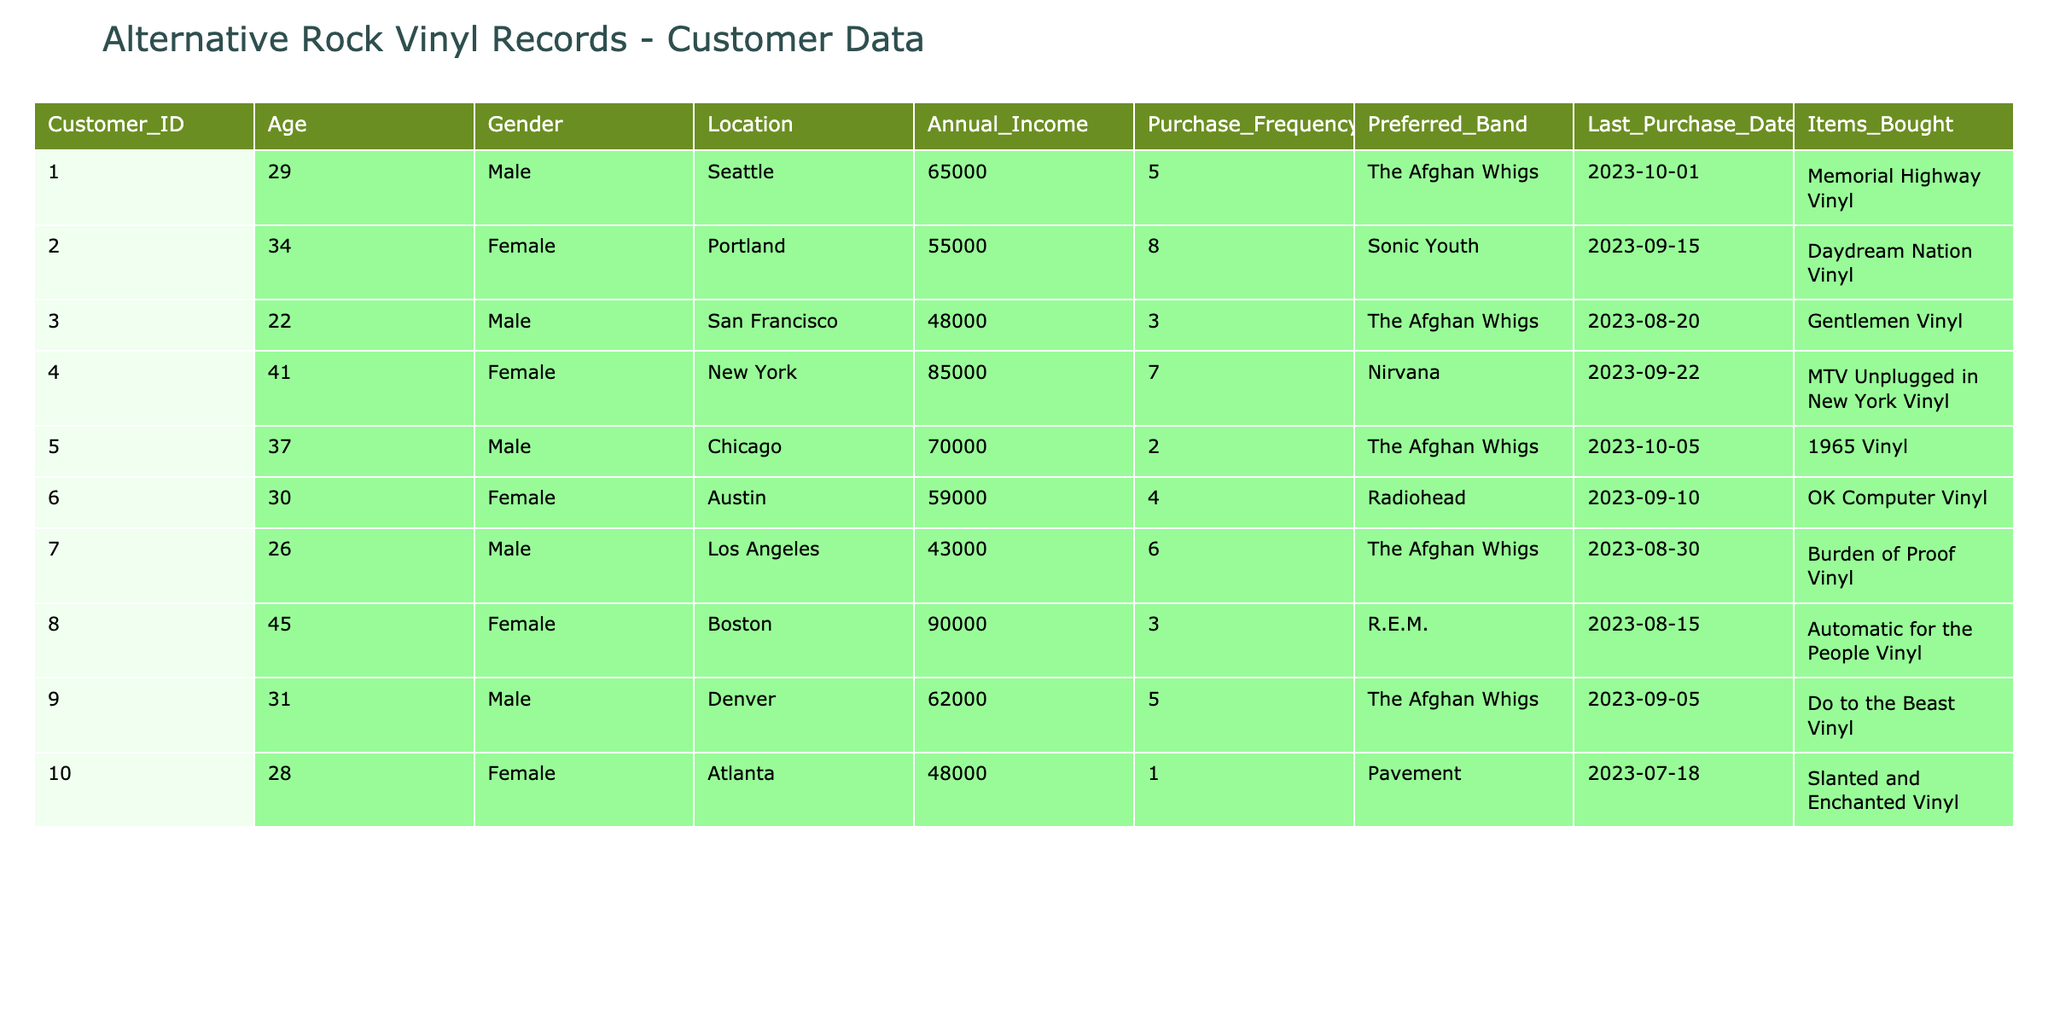What is the annual income of the customer who last purchased "Memorial Highway Vinyl"? The customer who last purchased "Memorial Highway Vinyl" is identified as Customer ID 1. Referring to the table, their annual income is listed as 65000.
Answer: 65000 What is the preferred band of the customer from Boston? The customer from Boston is identified as Customer ID 8. According to the table, their preferred band is R.E.M.
Answer: R.E.M How many customers have "The Afghan Whigs" as their preferred band? To answer this, I need to count the rows where the preferred band is "The Afghan Whigs." There are 4 customers with this preference (Customer IDs 1, 3, 5, and 7).
Answer: 4 What is the average age of the customers whose last purchase was in September 2023? First, I need to identify the customers who last purchased in September 2023, which includes Customer IDs 2, 4, 9, and 10. Their ages are 34, 41, 31, and 28 respectively. Adding these together gives a sum of 34 + 41 + 31 + 28 = 134. Since there are 4 customers, the average age is 134/4 = 33.5.
Answer: 33.5 Did any customer from Seattle have a purchase frequency of 5 or more? Looking at the information for Seattle, Customer ID 1 has a purchase frequency of 5. Therefore, the answer is Yes.
Answer: Yes Which band had the highest preferred count among the listed customers? By reviewing the preferences in the table, "The Afghan Whigs" is preferred by 4 customers. The counts for the other bands are as follows: Sonic Youth (1), Nirvana (1), Radiohead (1), R.E.M. (1), and Pavement (1). Since 4 is the highest count, "The Afghan Whigs" hold the title for the highest preferred count.
Answer: The Afghan Whigs What is the total purchase frequency of female customers? To determine this, look for female customers in the table: Customer IDs 2, 4, 6, and 8 have purchase frequencies of 8, 7, 4, and 3 respectively. The total frequency is 8 + 7 + 4 + 3 = 22.
Answer: 22 How many customers from Chicago last purchased a vinyl record in October 2023? In check for Chicago, Customer ID 5 is noted with a last purchase date of October 5, 2023. As this is the only customer from Chicago last purchasing in October, the answer is 1.
Answer: 1 